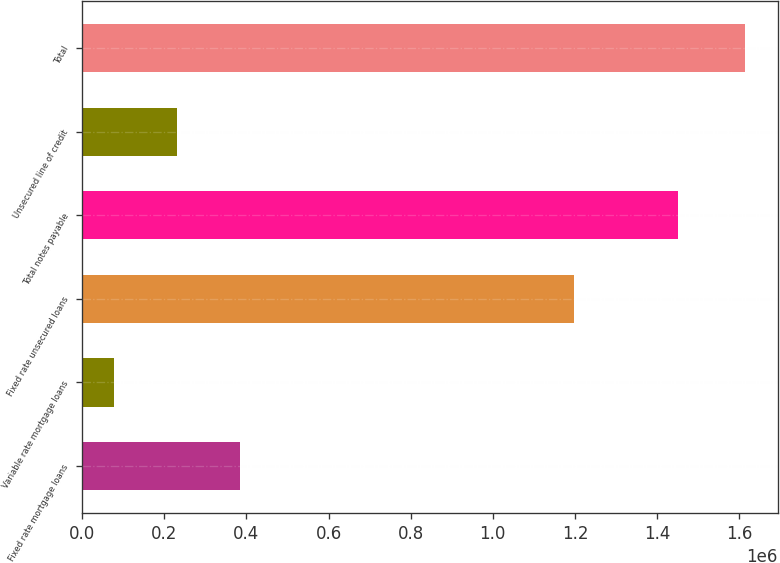Convert chart. <chart><loc_0><loc_0><loc_500><loc_500><bar_chart><fcel>Fixed rate mortgage loans<fcel>Variable rate mortgage loans<fcel>Fixed rate unsecured loans<fcel>Total notes payable<fcel>Unsecured line of credit<fcel>Total<nl><fcel>385113<fcel>77906<fcel>1.19863e+06<fcel>1.45194e+06<fcel>231510<fcel>1.61394e+06<nl></chart> 